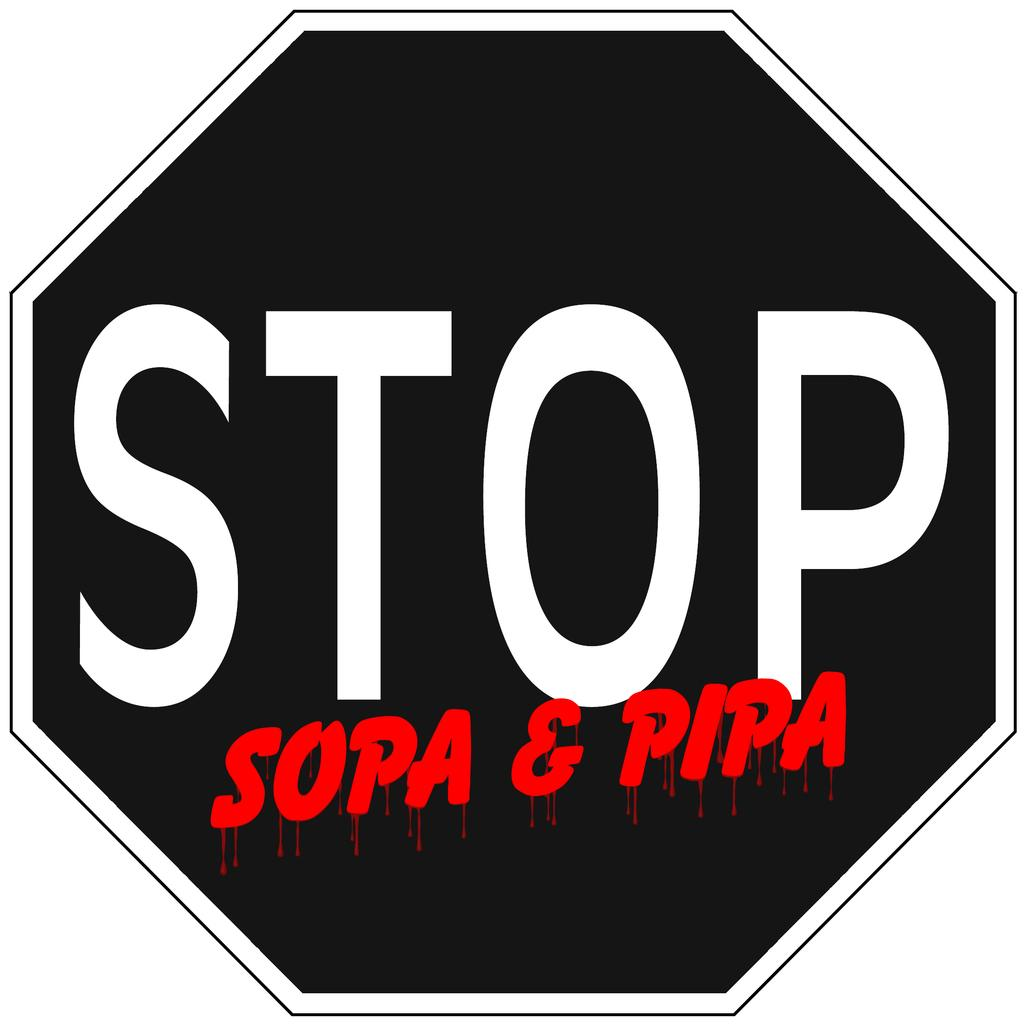What is the main object in the image? There is a signboard in the image. What can be found on the signboard? The signboard has text on it. What type of love spell is written on the signboard in the image? There is no mention of a love spell or any magic in the image; it only features a signboard with text on it. 